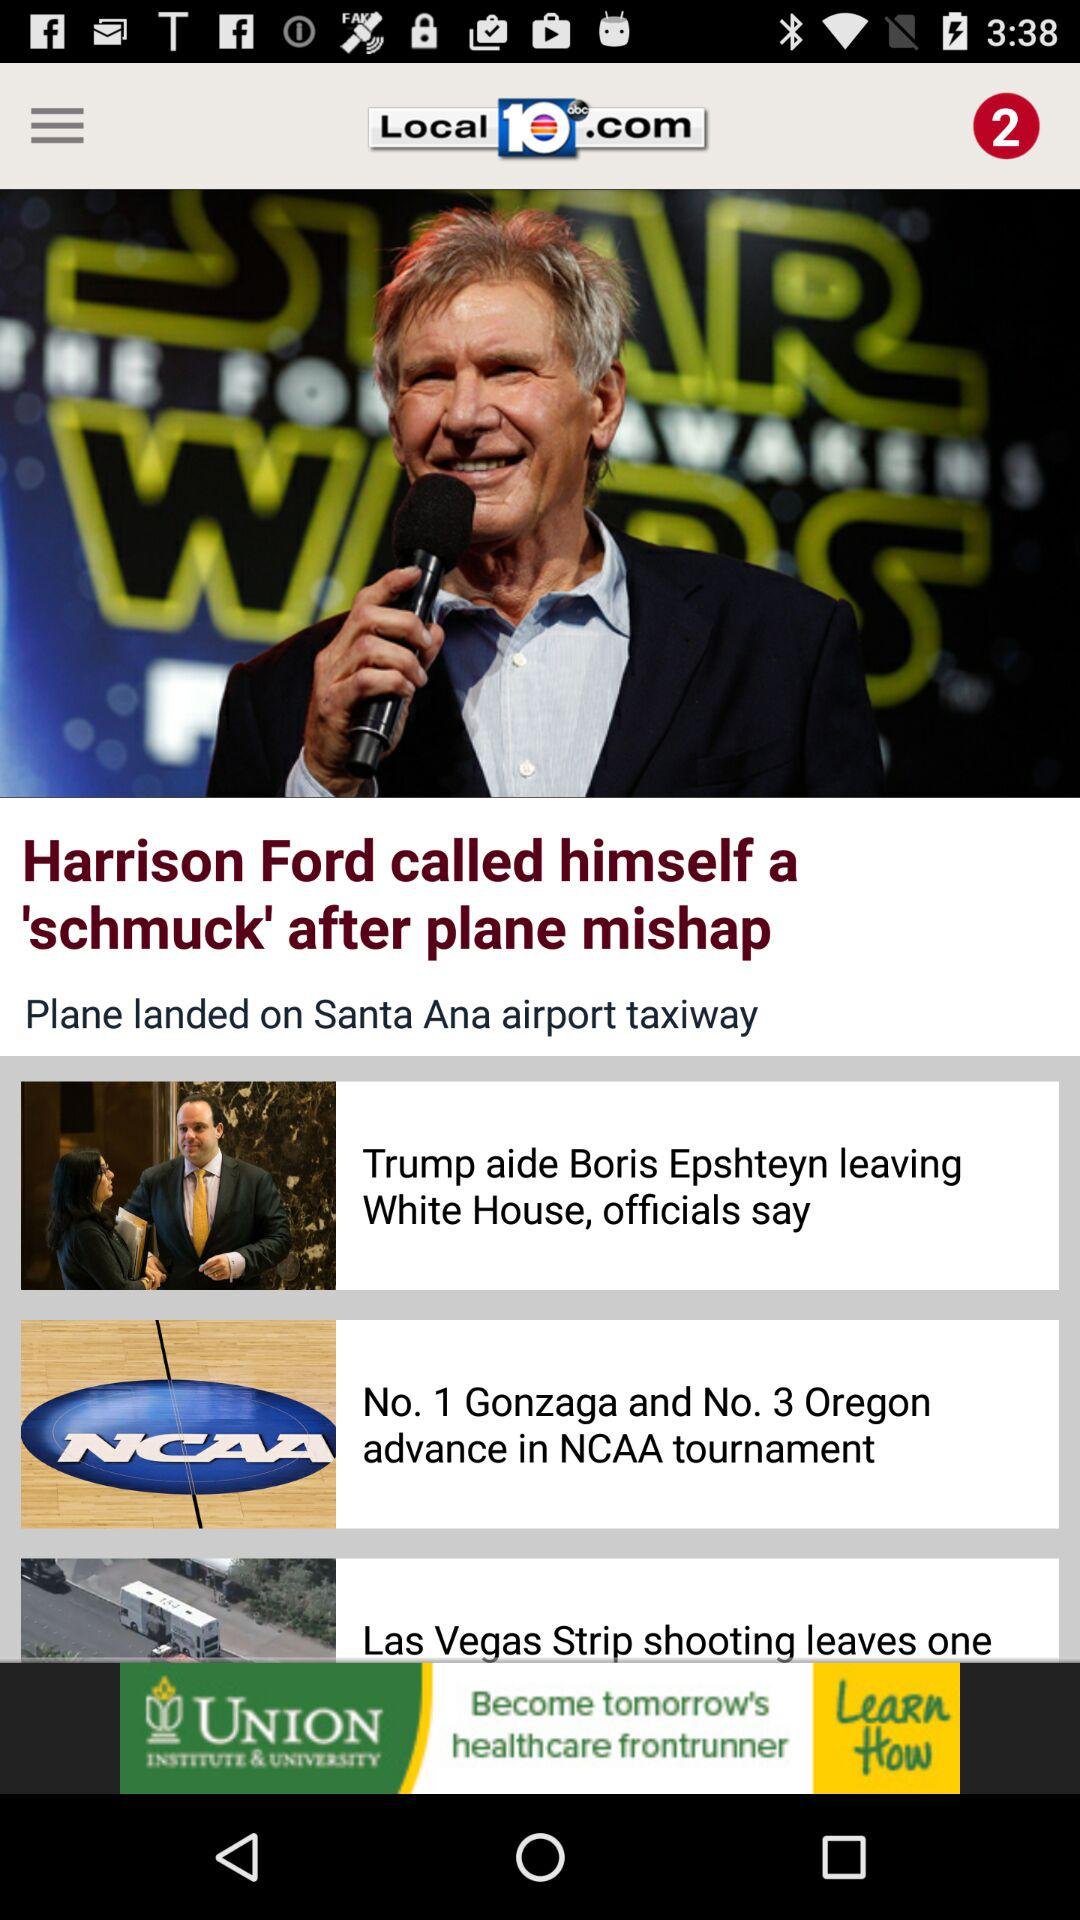What is the name of the website where the article is posted? The website name is "Local10.com". 